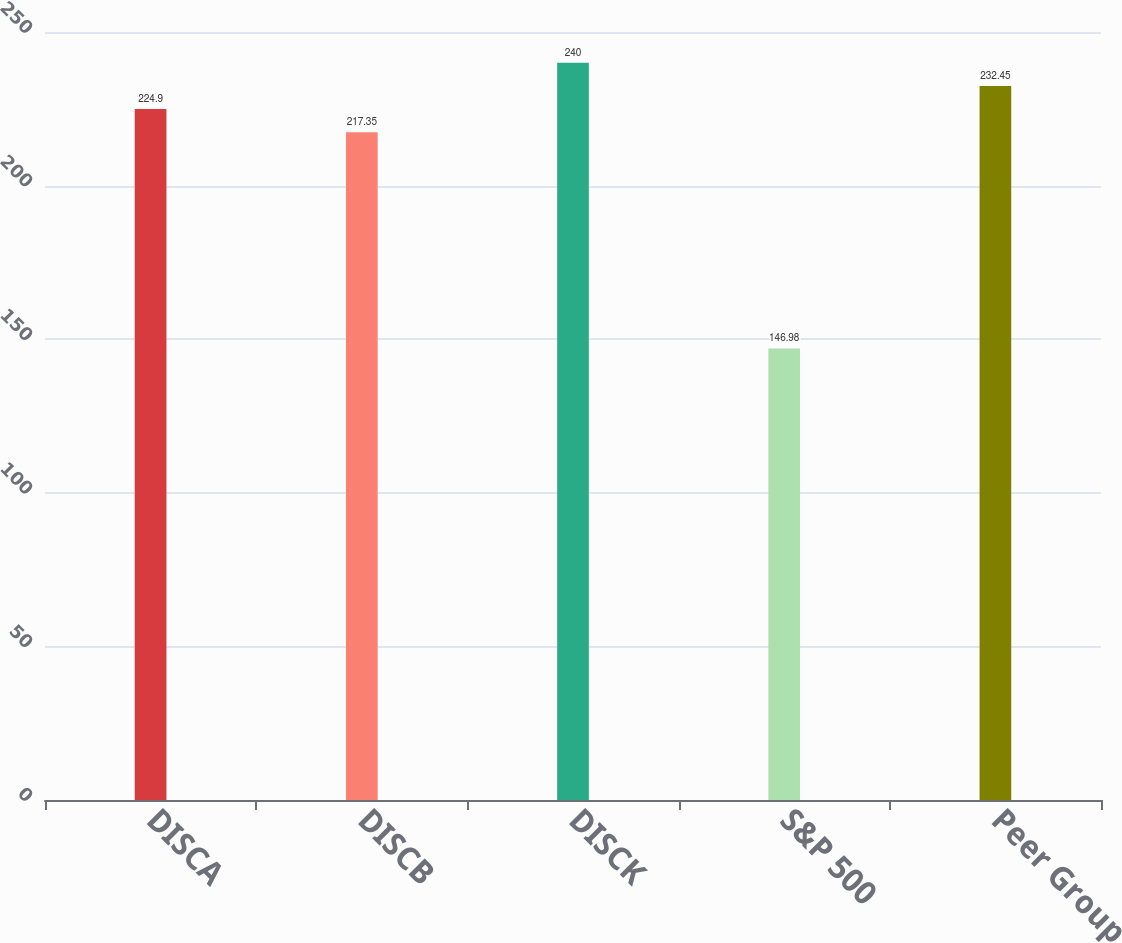Convert chart to OTSL. <chart><loc_0><loc_0><loc_500><loc_500><bar_chart><fcel>DISCA<fcel>DISCB<fcel>DISCK<fcel>S&P 500<fcel>Peer Group<nl><fcel>224.9<fcel>217.35<fcel>240<fcel>146.98<fcel>232.45<nl></chart> 